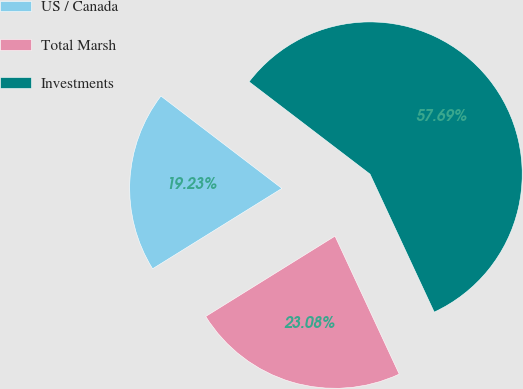Convert chart. <chart><loc_0><loc_0><loc_500><loc_500><pie_chart><fcel>US / Canada<fcel>Total Marsh<fcel>Investments<nl><fcel>19.23%<fcel>23.08%<fcel>57.69%<nl></chart> 